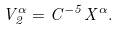<formula> <loc_0><loc_0><loc_500><loc_500>V _ { 2 } ^ { \alpha } = C ^ { - 5 } X ^ { \alpha } .</formula> 